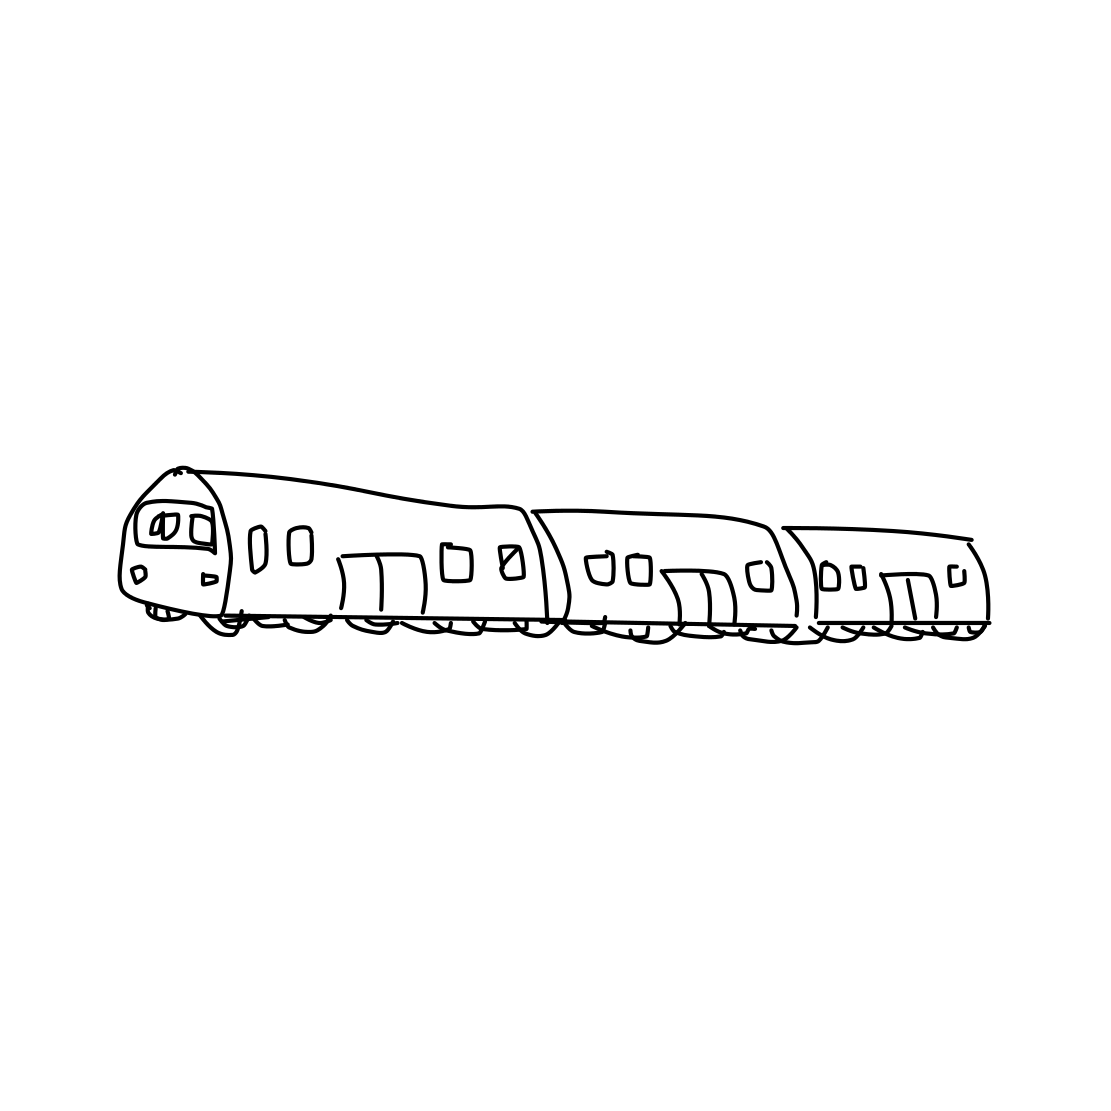What type of train is depicted in this sketch? The sketch seems to represent a passenger train, often used for regional or long-distance travel. The details like the streamlined shape and the positioning of the windows give it the appearance typical of passenger trains as opposed to freight trains. 